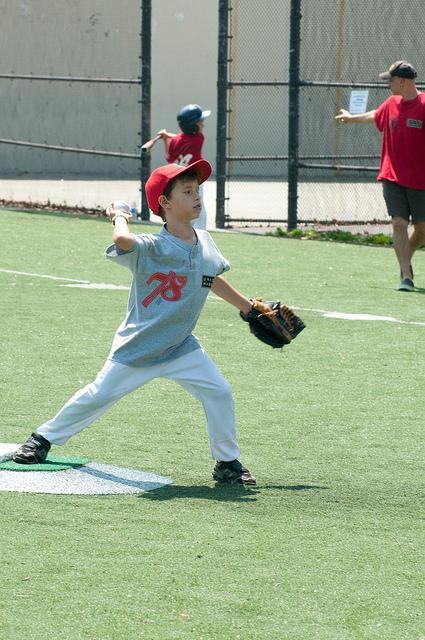What color is the boy's glove?
Quick response, please. Brown. Where is the boy looking?
Keep it brief. Forward. What sport is this boy playing?
Be succinct. Baseball. 